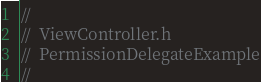Convert code to text. <code><loc_0><loc_0><loc_500><loc_500><_C_>//
//  ViewController.h
//  PermissionDelegateExample
//</code> 